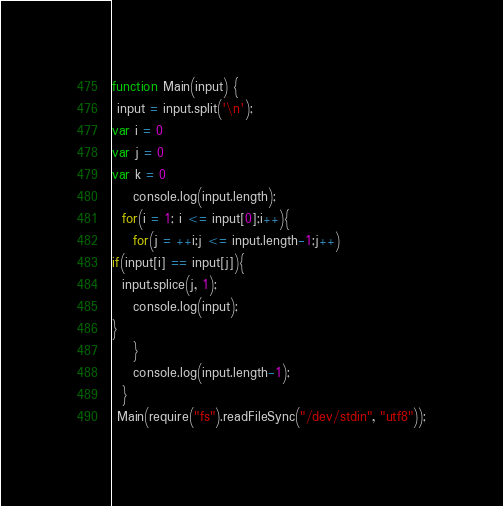Convert code to text. <code><loc_0><loc_0><loc_500><loc_500><_JavaScript_>function Main(input) {
 input = input.split('\n');
var i = 0
var j = 0
var k = 0
    console.log(input.length);
  for(i = 1; i <= input[0];i++){
    for(j = ++i;j <= input.length-1;j++)
if(input[i] == input[j]){
  input.splice(j, 1);
    console.log(input);
}
    }
    console.log(input.length-1);
  }
 Main(require("fs").readFileSync("/dev/stdin", "utf8"));</code> 